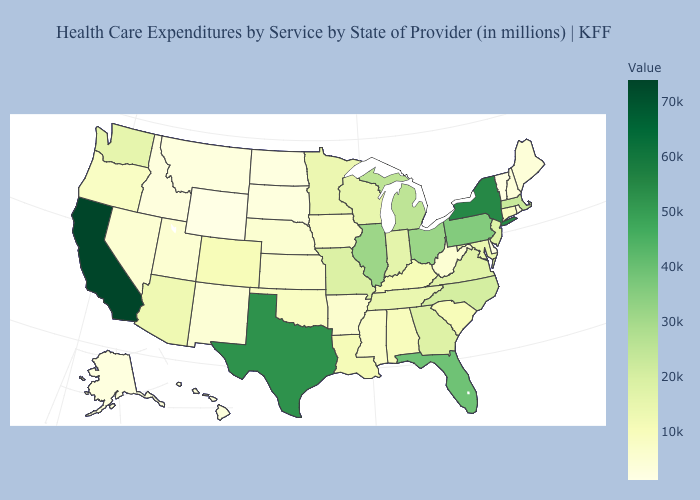Among the states that border West Virginia , which have the highest value?
Keep it brief. Pennsylvania. Does Wyoming have the highest value in the West?
Concise answer only. No. Does the map have missing data?
Give a very brief answer. No. Does the map have missing data?
Give a very brief answer. No. Which states have the lowest value in the Northeast?
Quick response, please. Vermont. Is the legend a continuous bar?
Keep it brief. Yes. Does Iowa have the highest value in the MidWest?
Quick response, please. No. Among the states that border Arkansas , which have the lowest value?
Keep it brief. Mississippi. Does the map have missing data?
Quick response, please. No. Does California have the highest value in the USA?
Quick response, please. Yes. 